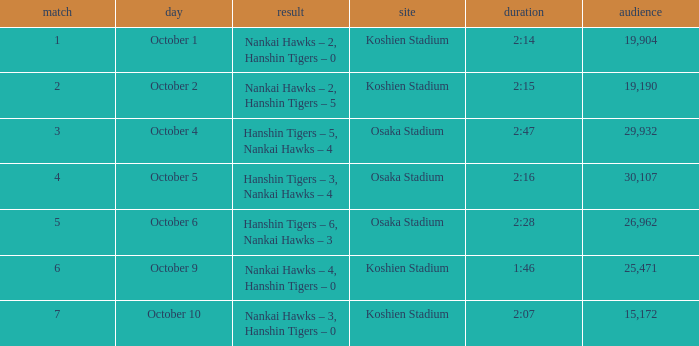Which Score has a Time of 2:28? Hanshin Tigers – 6, Nankai Hawks – 3. 